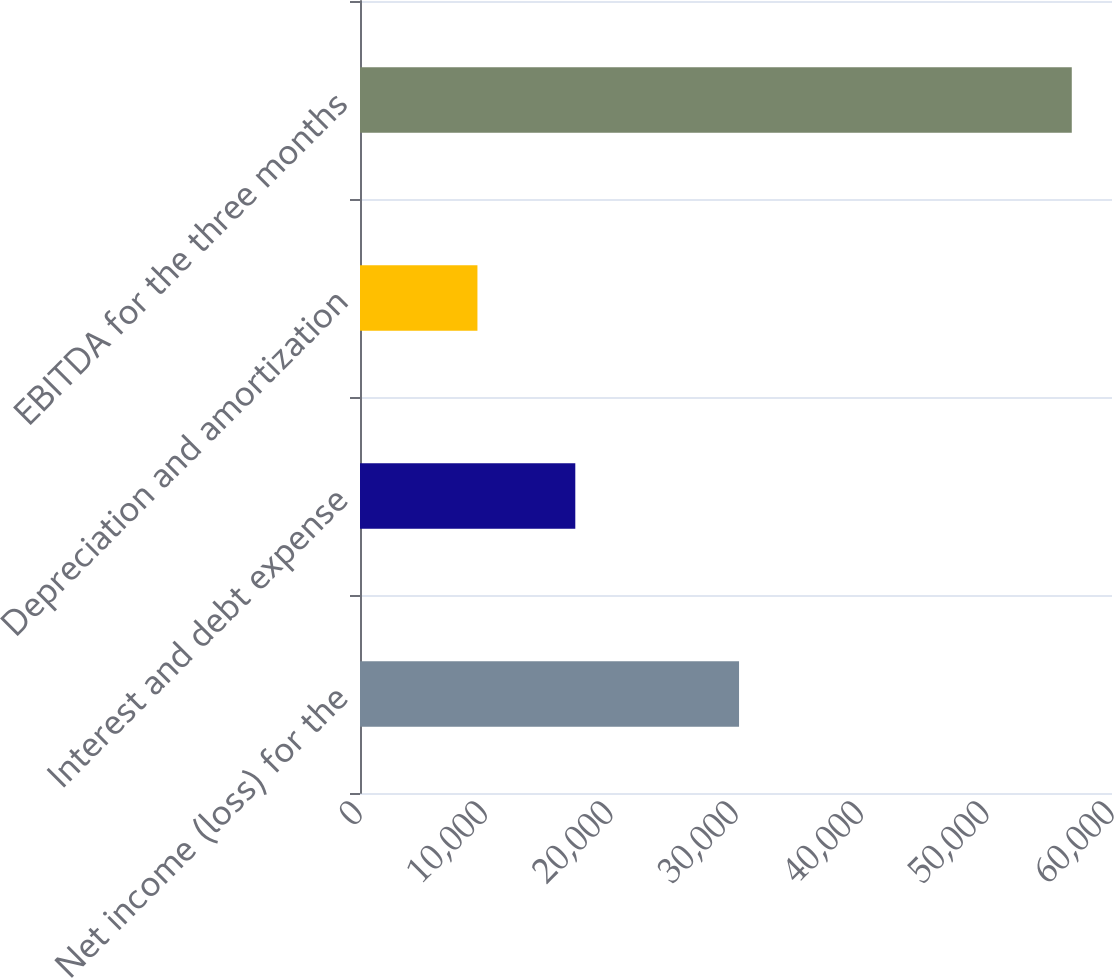Convert chart to OTSL. <chart><loc_0><loc_0><loc_500><loc_500><bar_chart><fcel>Net income (loss) for the<fcel>Interest and debt expense<fcel>Depreciation and amortization<fcel>EBITDA for the three months<nl><fcel>30243<fcel>17178<fcel>9370<fcel>56791<nl></chart> 